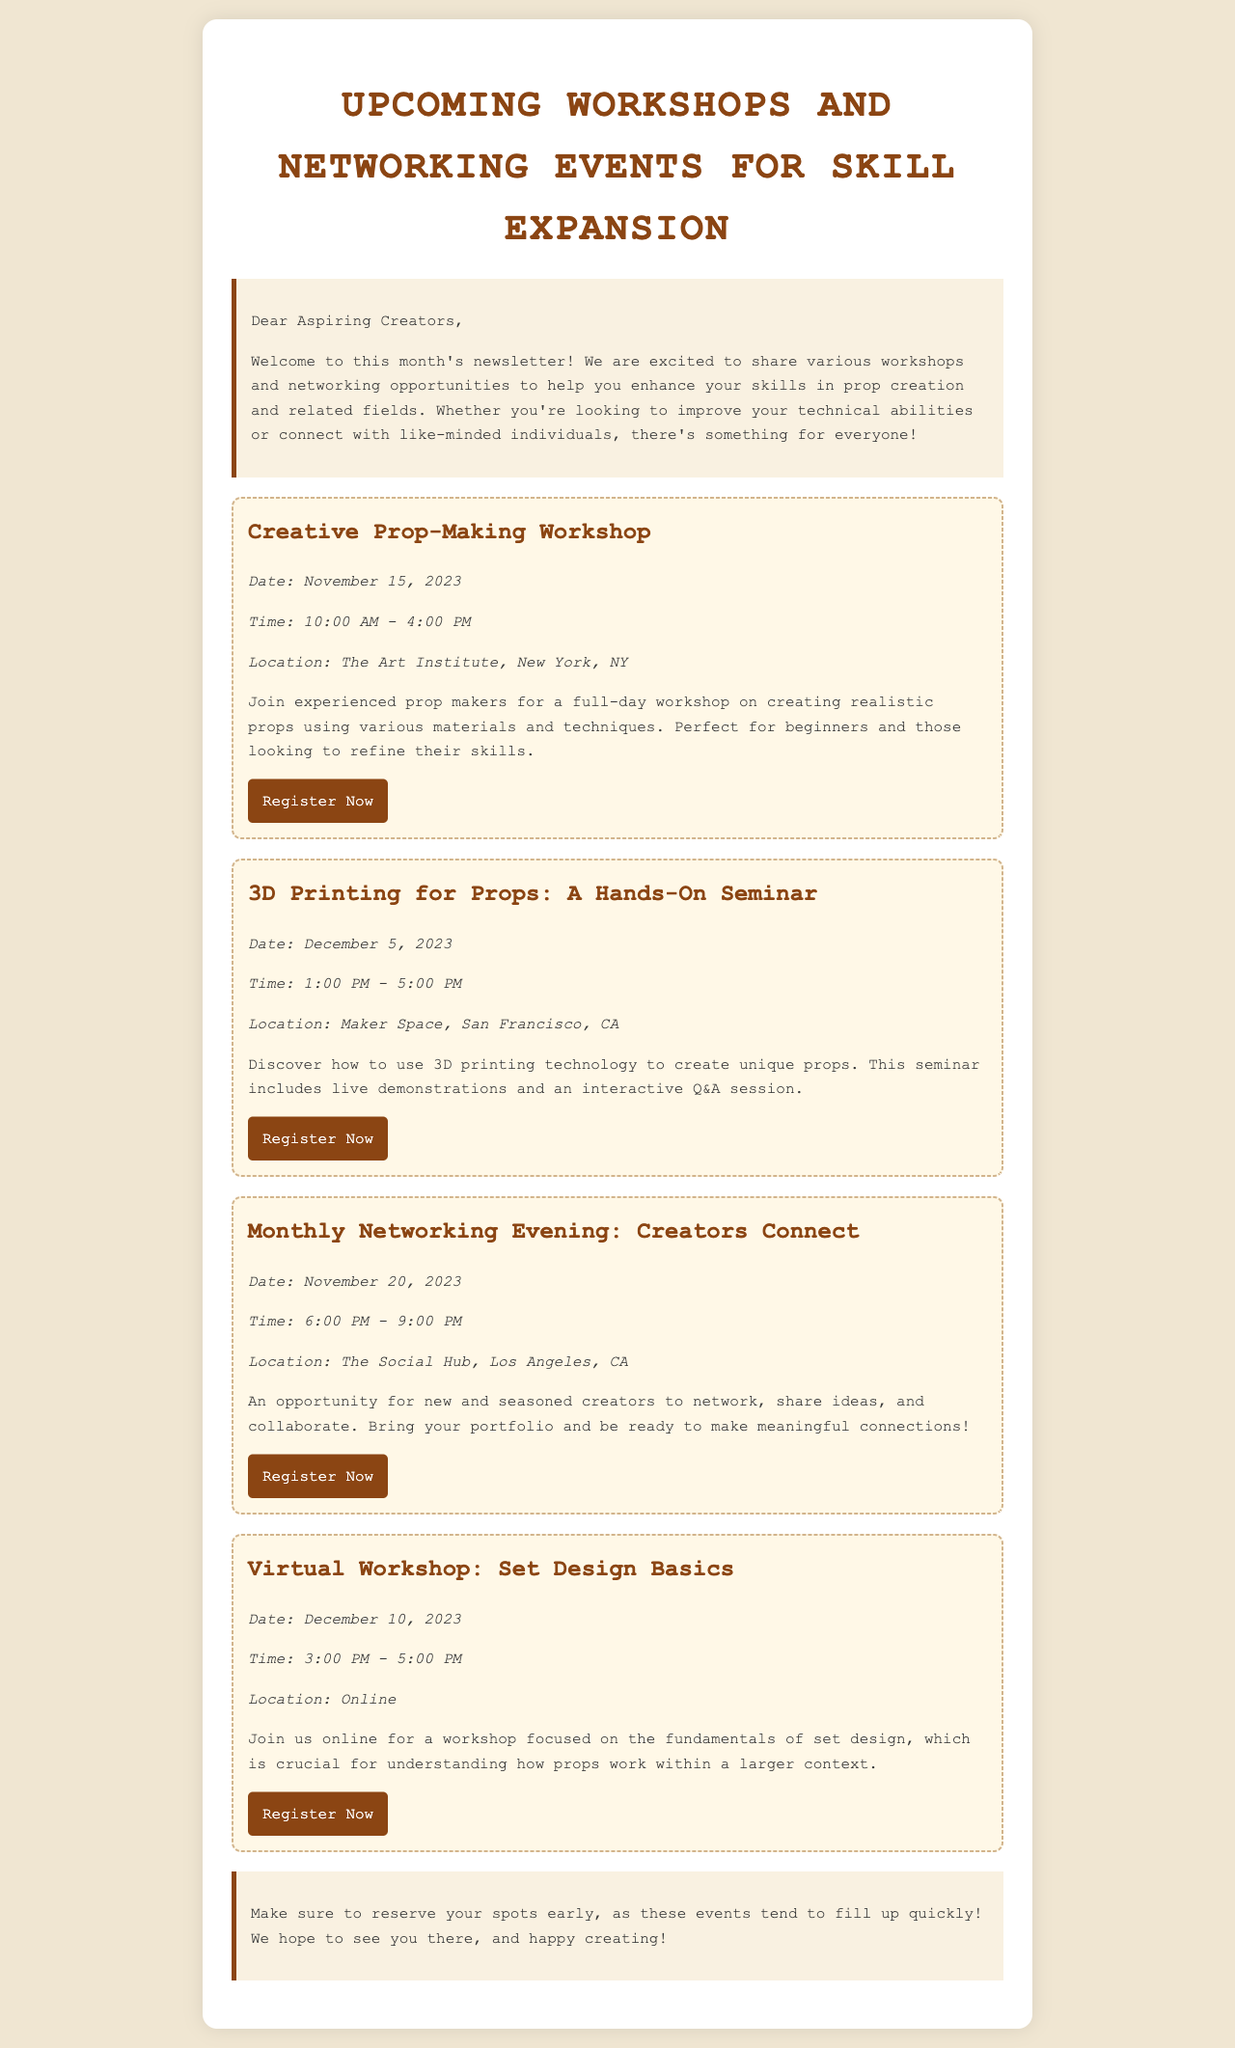what is the title of the newsletter? The title of the newsletter is prominently displayed at the top and indicates the theme of the content.
Answer: Upcoming Workshops and Networking Events for Skill Expansion what is the date of the Creative Prop-Making Workshop? The specific date is clearly stated within the event details section of that particular workshop.
Answer: November 15, 2023 where is the 3D Printing for Props seminar located? The location for the seminar is indicated under the event details section.
Answer: Maker Space, San Francisco, CA what time does the Monthly Networking Evening start? The starting time is provided in the event details section for that networking event.
Answer: 6:00 PM how many events are listed in the newsletter? Counting each listed workshop and networking event, this provides the total number of events mentioned.
Answer: Four what is the focus of the Virtual Workshop? The purpose or theme of the virtual workshop is described in the event description section.
Answer: Set design basics which workshop includes a live demonstration? The detail about the event that involves a demonstration can be found in the description of the respective seminar.
Answer: 3D Printing for Props: A Hands-On Seminar who is encouraged to bring their portfolio? The specific event description notes who should bring their portfolio for networking opportunities.
Answer: Participants of Monthly Networking Evening what should participants do early regarding the events? An action related to event registration is highlighted in the closing remarks of the newsletter.
Answer: Reserve your spots early 